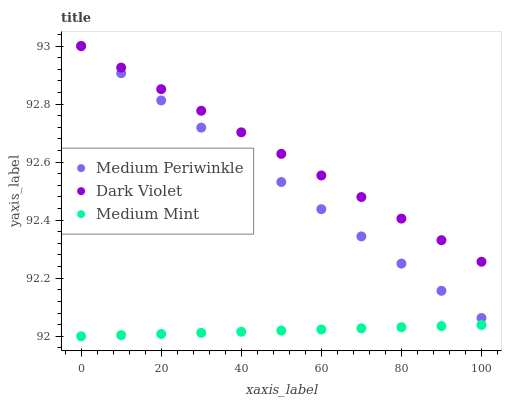Does Medium Mint have the minimum area under the curve?
Answer yes or no. Yes. Does Dark Violet have the maximum area under the curve?
Answer yes or no. Yes. Does Medium Periwinkle have the minimum area under the curve?
Answer yes or no. No. Does Medium Periwinkle have the maximum area under the curve?
Answer yes or no. No. Is Medium Mint the smoothest?
Answer yes or no. Yes. Is Dark Violet the roughest?
Answer yes or no. Yes. Is Medium Periwinkle the smoothest?
Answer yes or no. No. Is Medium Periwinkle the roughest?
Answer yes or no. No. Does Medium Mint have the lowest value?
Answer yes or no. Yes. Does Medium Periwinkle have the lowest value?
Answer yes or no. No. Does Dark Violet have the highest value?
Answer yes or no. Yes. Is Medium Mint less than Dark Violet?
Answer yes or no. Yes. Is Medium Periwinkle greater than Medium Mint?
Answer yes or no. Yes. Does Medium Periwinkle intersect Dark Violet?
Answer yes or no. Yes. Is Medium Periwinkle less than Dark Violet?
Answer yes or no. No. Is Medium Periwinkle greater than Dark Violet?
Answer yes or no. No. Does Medium Mint intersect Dark Violet?
Answer yes or no. No. 